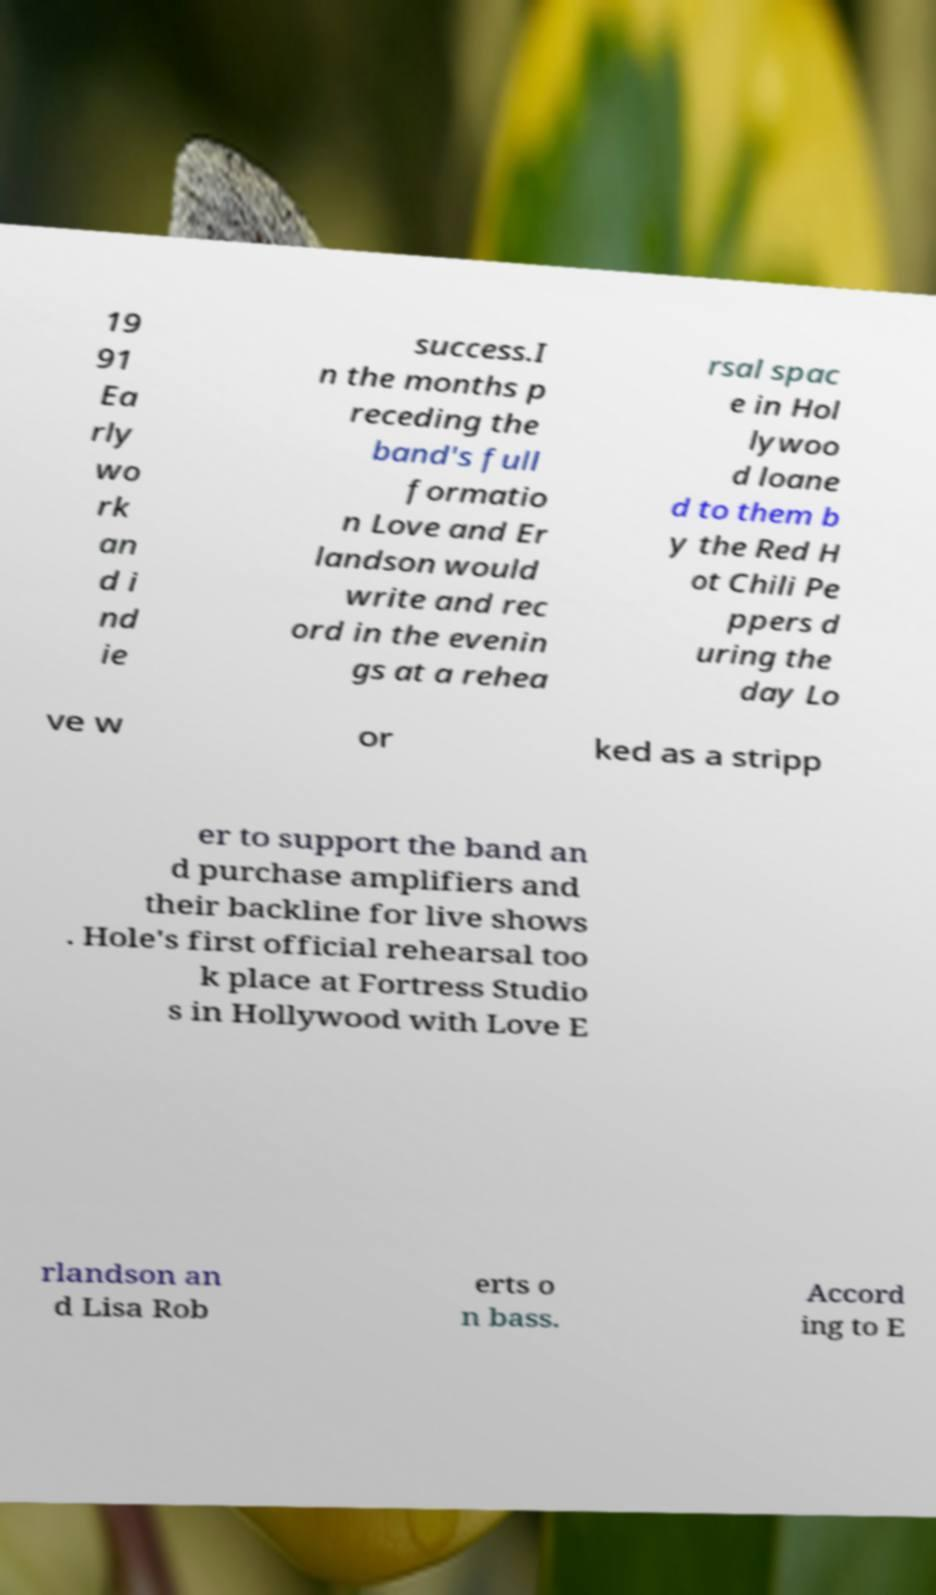For documentation purposes, I need the text within this image transcribed. Could you provide that? 19 91 Ea rly wo rk an d i nd ie success.I n the months p receding the band's full formatio n Love and Er landson would write and rec ord in the evenin gs at a rehea rsal spac e in Hol lywoo d loane d to them b y the Red H ot Chili Pe ppers d uring the day Lo ve w or ked as a stripp er to support the band an d purchase amplifiers and their backline for live shows . Hole's first official rehearsal too k place at Fortress Studio s in Hollywood with Love E rlandson an d Lisa Rob erts o n bass. Accord ing to E 